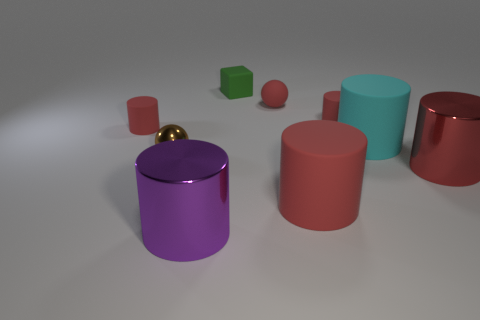What is the material of the small red ball?
Offer a terse response. Rubber. There is a block; how many rubber cylinders are in front of it?
Provide a short and direct response. 4. Are the small cylinder that is on the right side of the metal sphere and the small green block made of the same material?
Your response must be concise. Yes. How many brown metallic objects are the same shape as the cyan matte object?
Offer a very short reply. 0. What number of small objects are either red things or green balls?
Offer a very short reply. 3. There is a tiny cylinder on the right side of the purple thing; does it have the same color as the tiny rubber sphere?
Provide a short and direct response. Yes. Does the big matte cylinder that is in front of the brown object have the same color as the tiny rubber thing that is left of the green object?
Keep it short and to the point. Yes. Are there any tiny yellow spheres made of the same material as the cyan cylinder?
Provide a short and direct response. No. How many red objects are either big shiny cylinders or tiny cubes?
Keep it short and to the point. 1. Is the number of purple metal objects that are on the left side of the green cube greater than the number of small yellow rubber cylinders?
Give a very brief answer. Yes. 